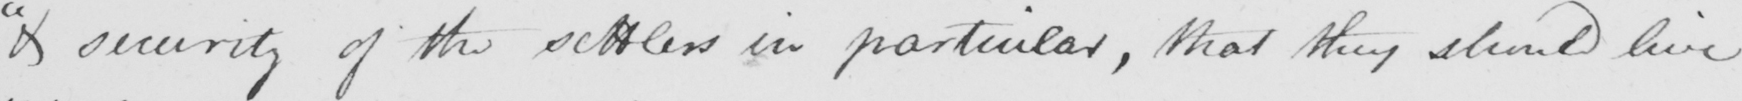Can you tell me what this handwritten text says? " & security of the settlers in particular , that they should live 